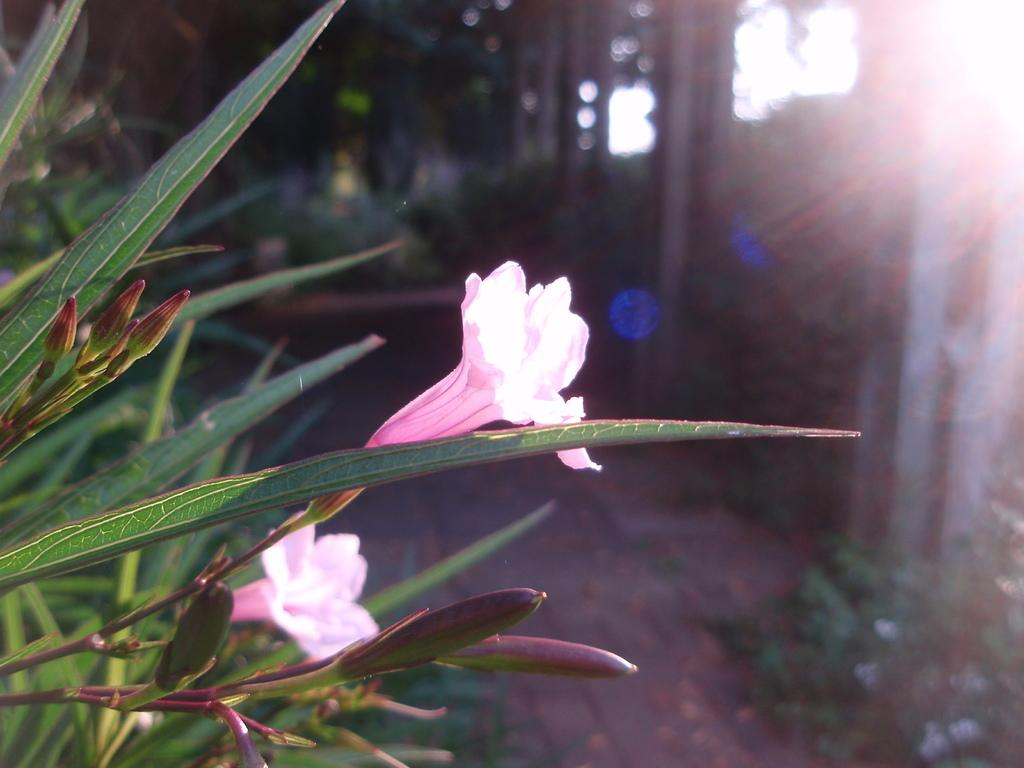What type of plants can be seen in the image? There are plants with flowers in the image. What part of the natural environment is visible in the image? The ground and the sky are visible in the image. What structures can be seen in the image? There are poles in the image. What type of committee is meeting under the arch in the image? There is no committee or arch present in the image; it features plants with flowers, the ground, sky, and poles. How many snakes are slithering through the plants in the image? There are no snakes present in the image; it features plants with flowers, the ground, sky, and poles. 